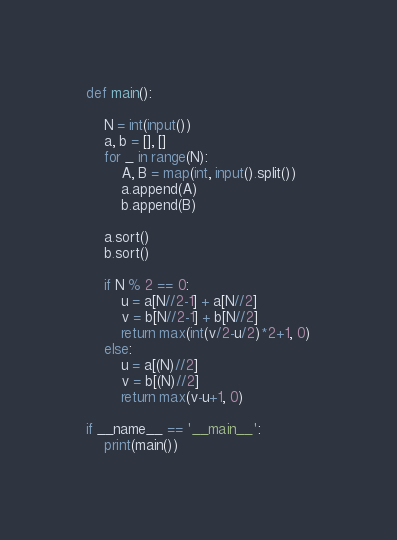Convert code to text. <code><loc_0><loc_0><loc_500><loc_500><_Python_>def main():

    N = int(input())
    a, b = [], []
    for _ in range(N):
        A, B = map(int, input().split())
        a.append(A)
        b.append(B)

    a.sort()
    b.sort()

    if N % 2 == 0:
        u = a[N//2-1] + a[N//2]
        v = b[N//2-1] + b[N//2]
        return max(int(v/2-u/2)*2+1, 0)
    else:
        u = a[(N)//2]
        v = b[(N)//2]
        return max(v-u+1, 0)

if __name__ == '__main__':
    print(main())
</code> 